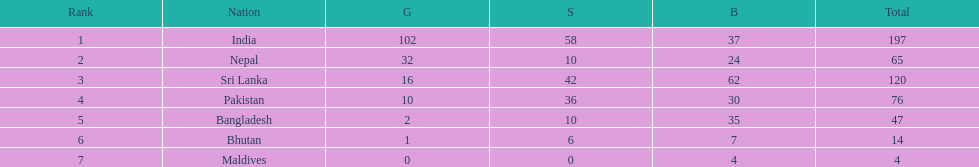What is the count of gold medals that nepal has won over pakistan? 22. 